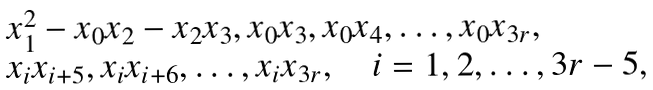Convert formula to latex. <formula><loc_0><loc_0><loc_500><loc_500>\begin{array} { l } x _ { 1 } ^ { 2 } - x _ { 0 } x _ { 2 } - x _ { 2 } x _ { 3 } , x _ { 0 } x _ { 3 } , x _ { 0 } x _ { 4 } , \dots , x _ { 0 } x _ { 3 r } , \\ x _ { i } x _ { i + 5 } , x _ { i } x _ { i + 6 } , \dots , x _ { i } x _ { 3 r } , \quad i = 1 , 2 , \dots , 3 r - 5 , \\ \end{array}</formula> 